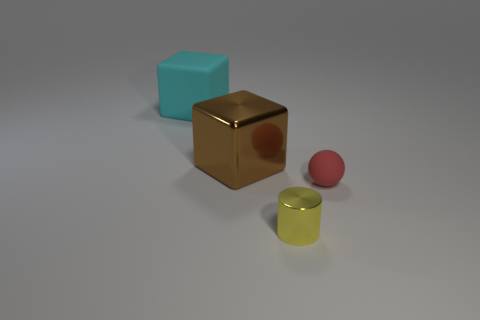Is the number of small matte things greater than the number of purple spheres?
Keep it short and to the point. Yes. Is the material of the tiny red object the same as the tiny cylinder?
Make the answer very short. No. Is there anything else that has the same material as the brown block?
Give a very brief answer. Yes. Are there more objects that are to the right of the big cyan rubber object than big yellow balls?
Make the answer very short. Yes. What number of red objects are the same shape as the brown object?
Your answer should be compact. 0. The brown cube that is made of the same material as the small yellow thing is what size?
Offer a very short reply. Large. The thing that is to the left of the red matte object and in front of the brown metal cube is what color?
Make the answer very short. Yellow. What number of brown objects have the same size as the yellow cylinder?
Keep it short and to the point. 0. What size is the thing that is both in front of the brown shiny thing and on the left side of the small red matte ball?
Your answer should be very brief. Small. There is a big cyan matte thing left of the yellow metal cylinder that is left of the small ball; what number of objects are left of it?
Give a very brief answer. 0. 